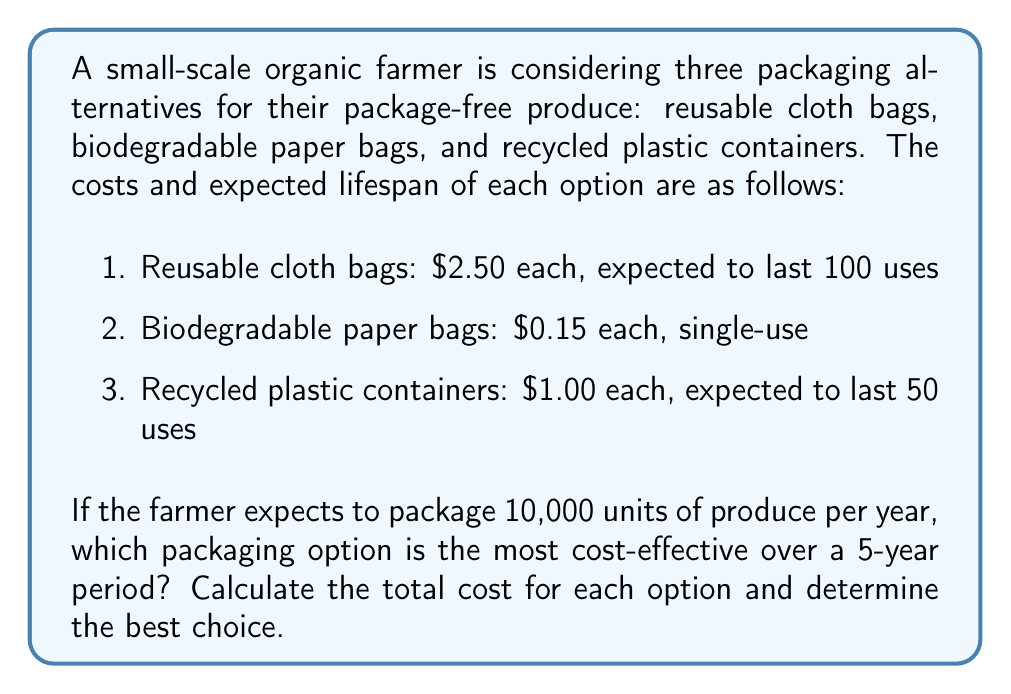Could you help me with this problem? To determine the most cost-effective packaging option, we need to calculate the total cost for each alternative over the 5-year period. Let's break it down step by step:

1. Calculate the total number of units to be packaged over 5 years:
   $$\text{Total units} = 10,000 \text{ units/year} \times 5 \text{ years} = 50,000 \text{ units}$$

2. Calculate the cost for each option:

   a. Reusable cloth bags:
      - Number of bags needed: $$\frac{50,000 \text{ units}}{100 \text{ uses/bag}} = 500 \text{ bags}$$
      - Total cost: $$500 \text{ bags} \times \$2.50/\text{bag} = \$1,250$$

   b. Biodegradable paper bags:
      - Number of bags needed: 50,000 (one bag per unit)
      - Total cost: $$50,000 \text{ bags} \times \$0.15/\text{bag} = \$7,500$$

   c. Recycled plastic containers:
      - Number of containers needed: $$\frac{50,000 \text{ units}}{50 \text{ uses/container}} = 1,000 \text{ containers}$$
      - Total cost: $$1,000 \text{ containers} \times \$1.00/\text{container} = \$1,000$$

3. Compare the total costs:
   - Reusable cloth bags: $1,250
   - Biodegradable paper bags: $7,500
   - Recycled plastic containers: $1,000

The recycled plastic containers have the lowest total cost over the 5-year period, making them the most cost-effective option.
Answer: The most cost-effective packaging option over the 5-year period is the recycled plastic containers, with a total cost of $1,000. 